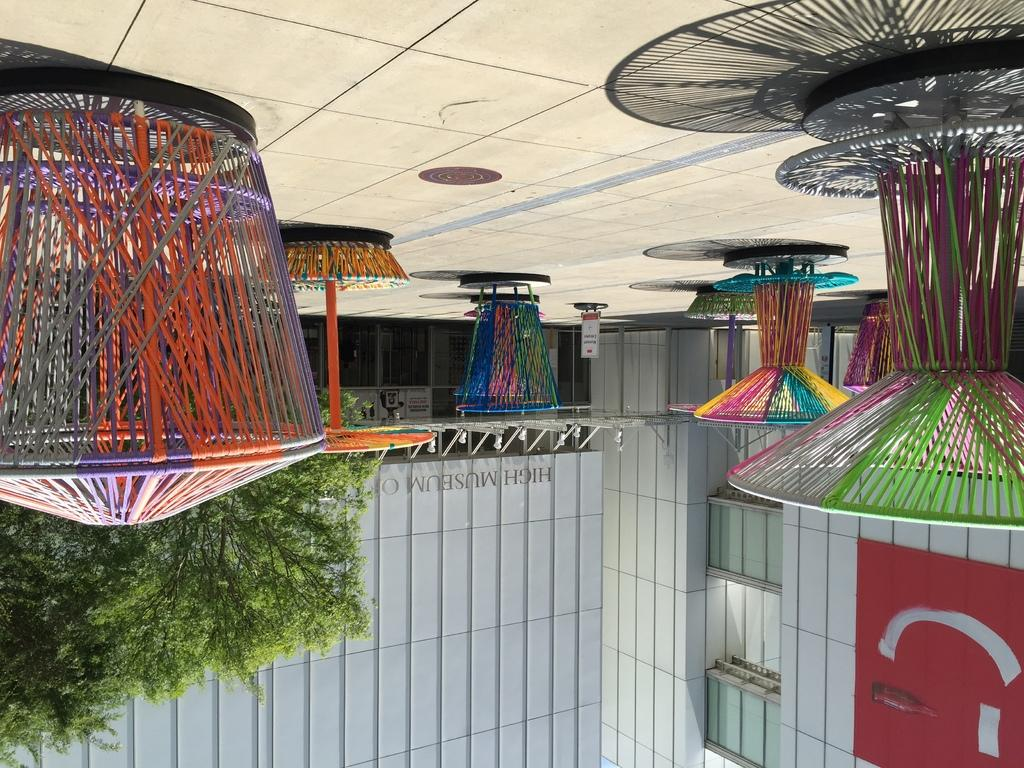What can be seen on the ground in the image? There are colorful objects on the ground in the image. What is visible in the distance behind the objects? There are buildings and trees in the background of the image. What does the person in the image regret? There is no person present in the image, so it is impossible to determine if they have any regrets. 